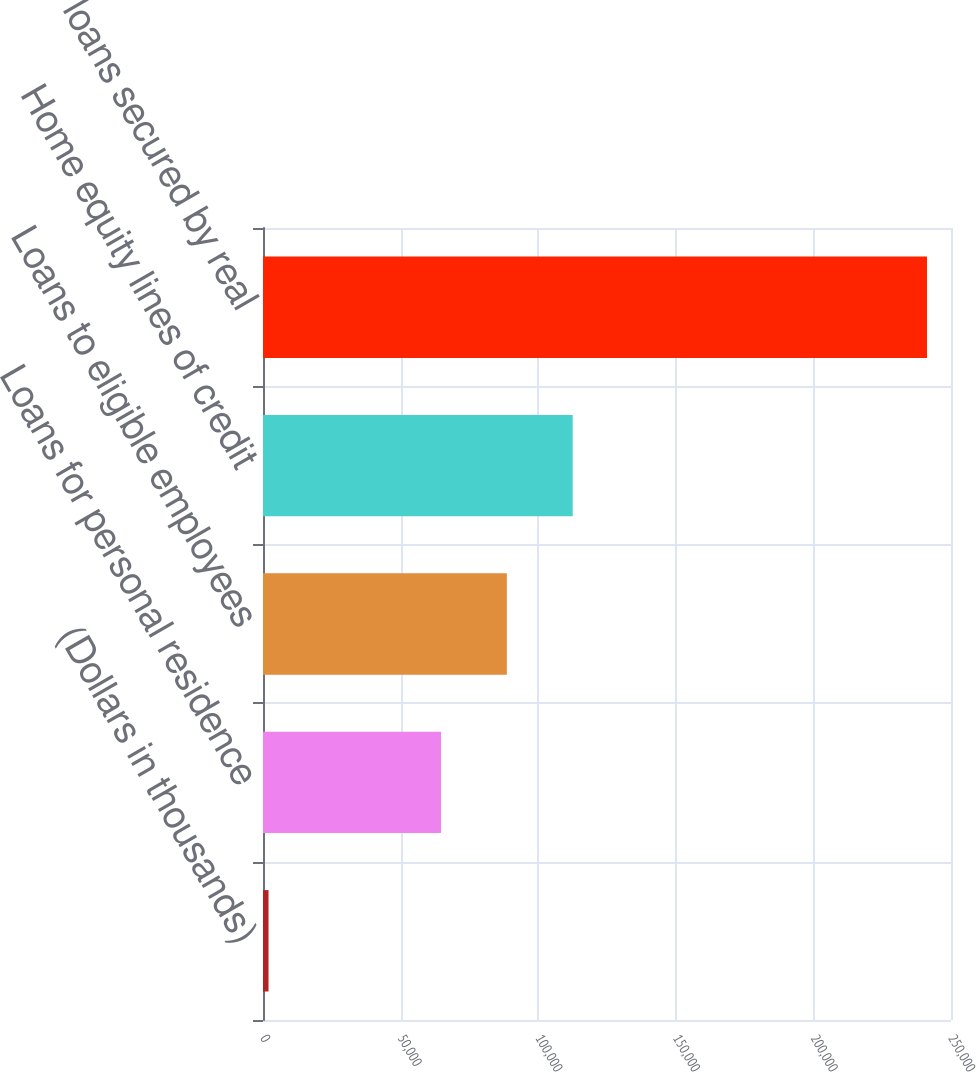Convert chart to OTSL. <chart><loc_0><loc_0><loc_500><loc_500><bar_chart><fcel>(Dollars in thousands)<fcel>Loans for personal residence<fcel>Loans to eligible employees<fcel>Home equity lines of credit<fcel>Consumer loans secured by real<nl><fcel>2009<fcel>64678<fcel>88605.5<fcel>112533<fcel>241284<nl></chart> 